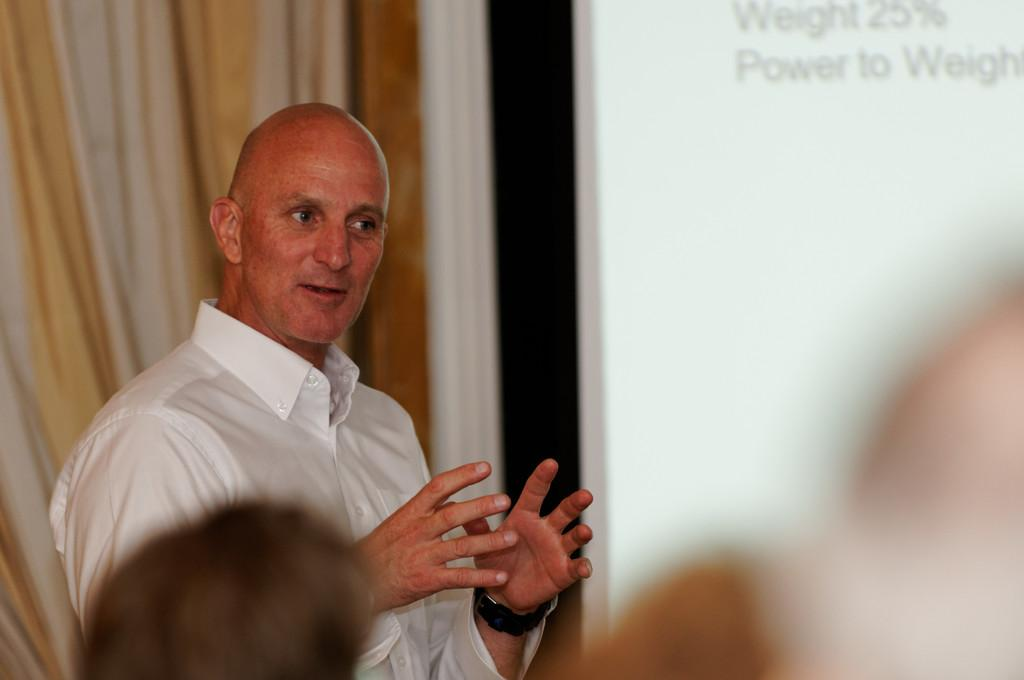Who is the main subject in the image? There is a person in the image. What is the relationship between the person and the people in front of them? The people are in front of the person, but their relationship is not specified in the image. What is the background element behind the person? There is a curtain behind the person. How many sisters does the person in the image have? There is no information about the person's sisters in the image. 